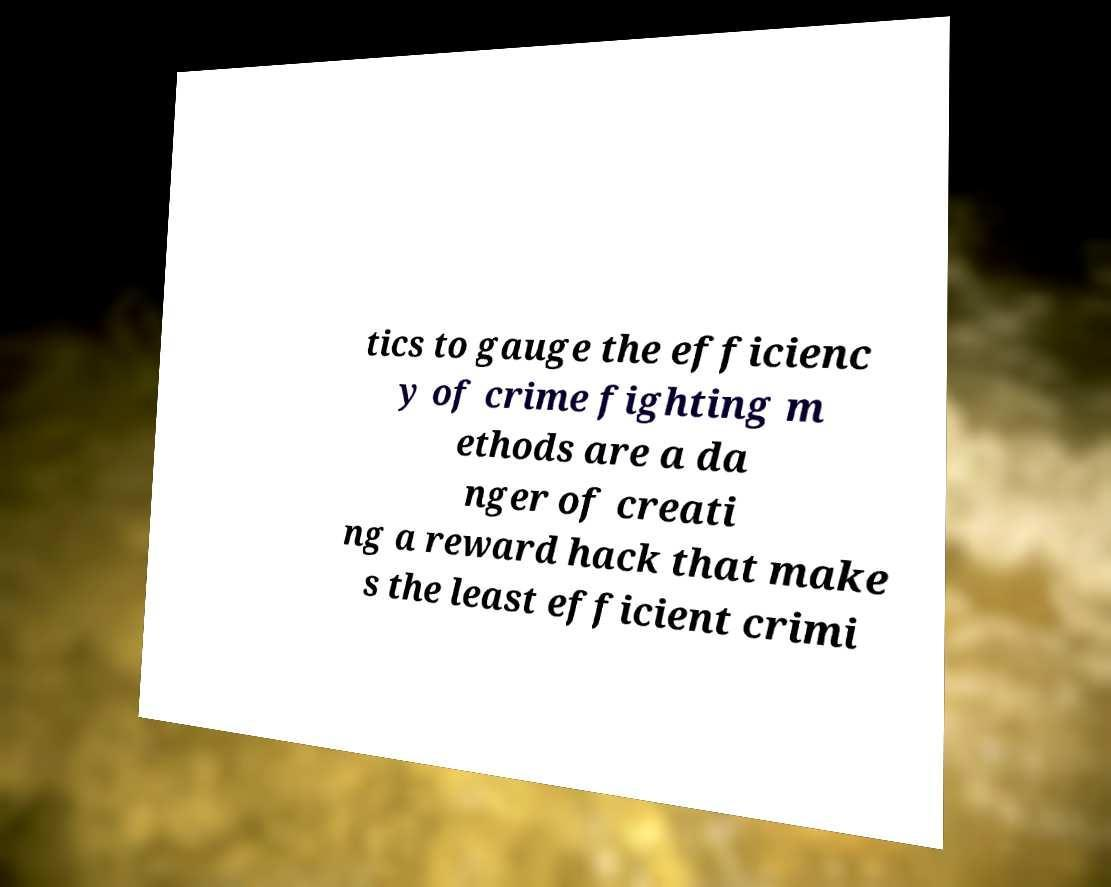What messages or text are displayed in this image? I need them in a readable, typed format. tics to gauge the efficienc y of crime fighting m ethods are a da nger of creati ng a reward hack that make s the least efficient crimi 